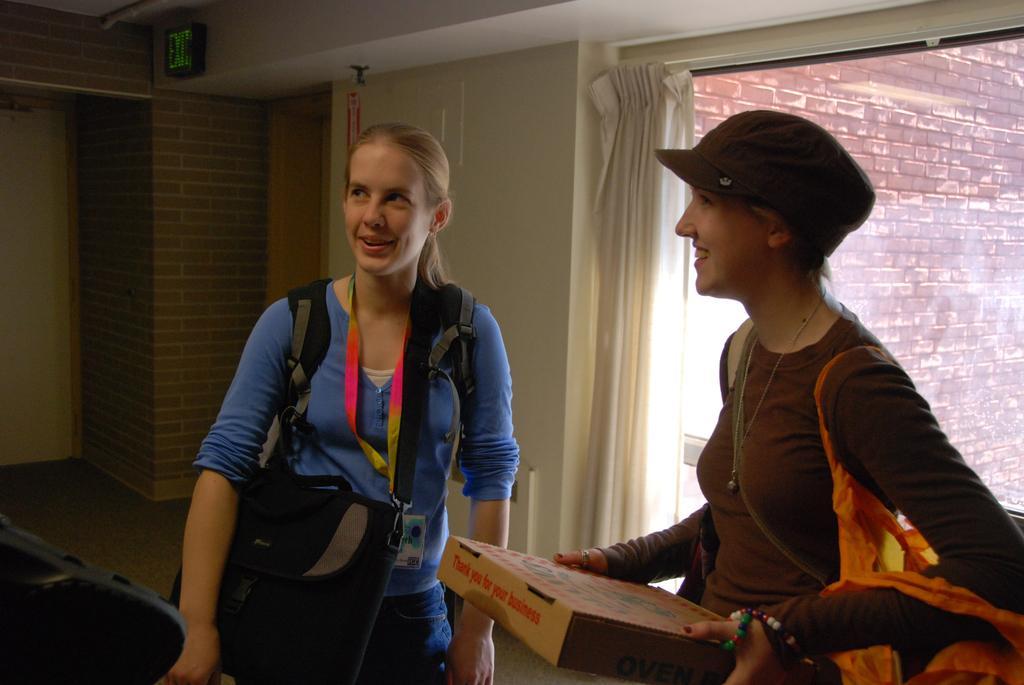In one or two sentences, can you explain what this image depicts? On the right side of the image a lady is standing and holding a box and carrying a bag and wearing a hat. On the left side of the image a lady is standing and carrying a bag. In the background of the image we can see a signboard, curtain, window, wall are present. At the bottom of the image floor is there. At the top of the image roof is present. 